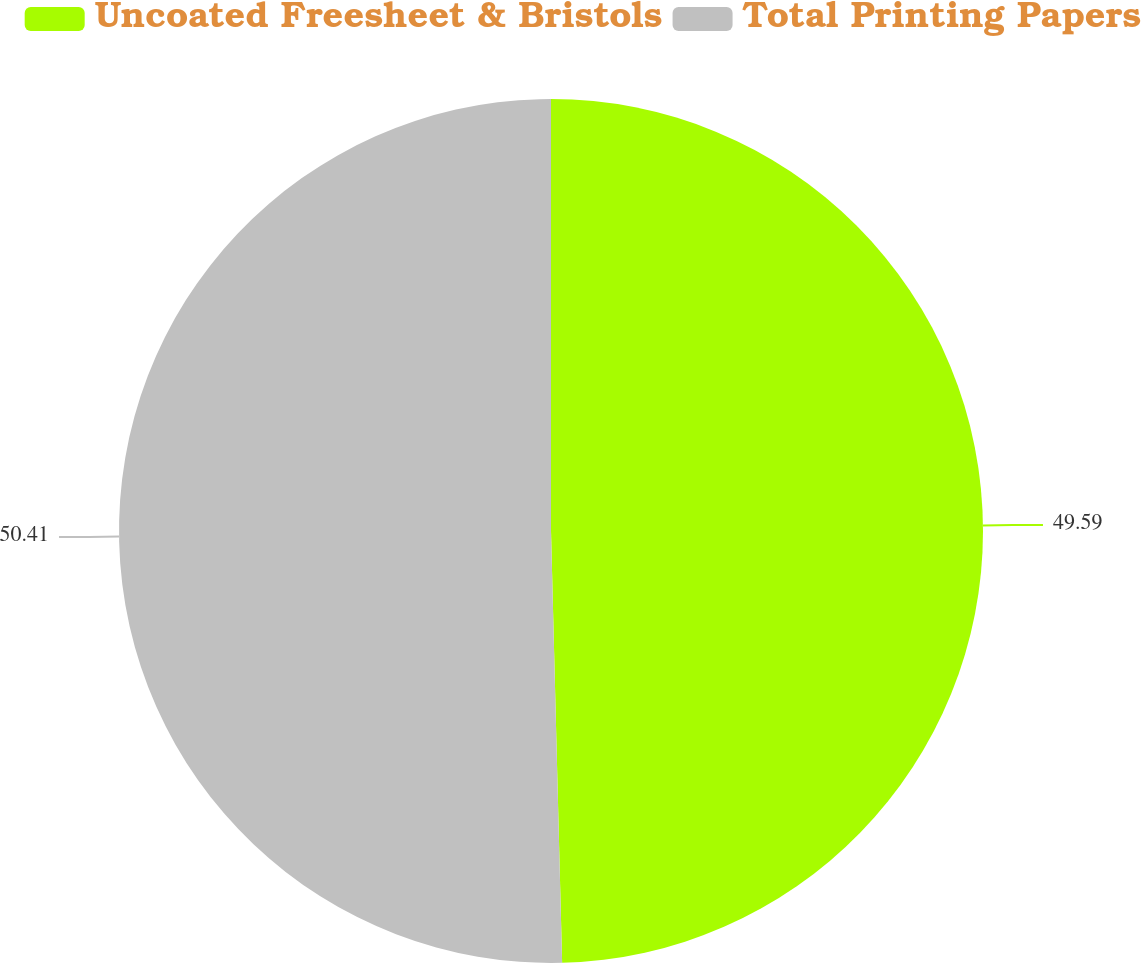Convert chart to OTSL. <chart><loc_0><loc_0><loc_500><loc_500><pie_chart><fcel>Uncoated Freesheet & Bristols<fcel>Total Printing Papers<nl><fcel>49.59%<fcel>50.41%<nl></chart> 